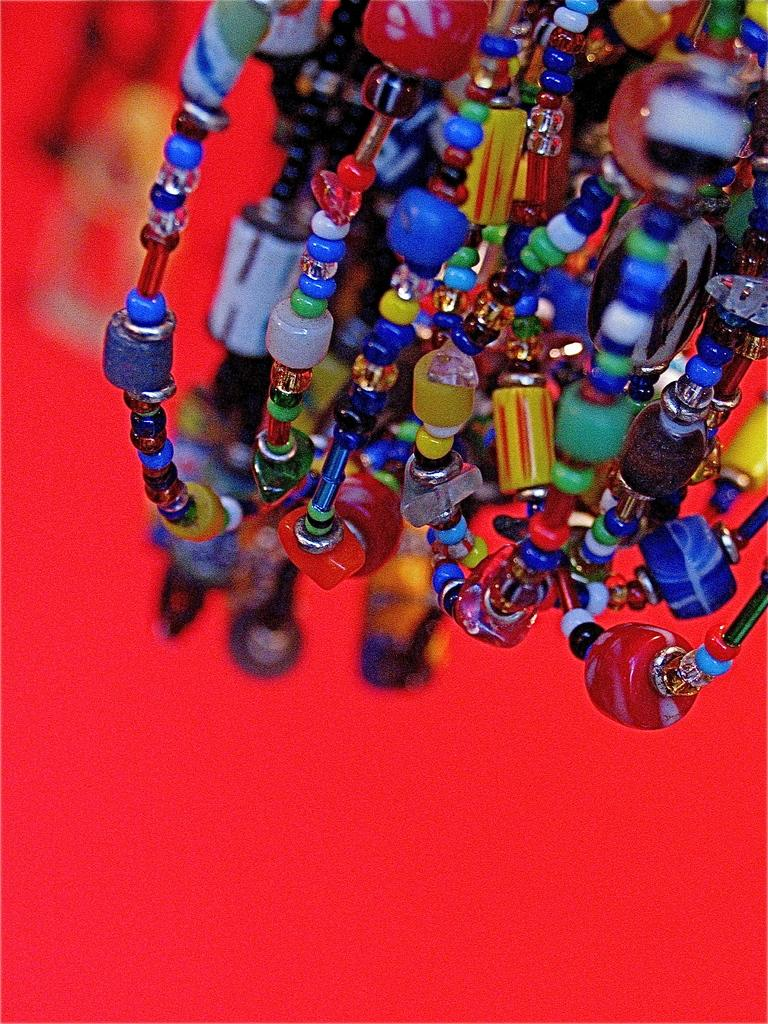What is located at the top of the image? There are beads at the top of the image. What color is present at the bottom of the image? The bottom of the image is in red color. What type of dinner is being served in the image? There is no dinner present in the image; it only features beads at the top and a red color at the bottom. How does the jelly contribute to the power supply in the image? There is no jelly or power supply mentioned in the image; it only contains beads at the top and a red color at the bottom. 